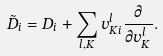Convert formula to latex. <formula><loc_0><loc_0><loc_500><loc_500>\tilde { D } _ { i } = D _ { i } + \sum _ { l , K } v _ { K i } ^ { l } \frac { \partial } { \partial v _ { K } ^ { l } } .</formula> 